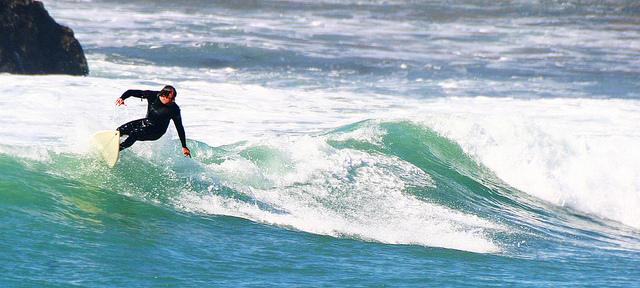Is there a wave in the picture?
Quick response, please. Yes. What is this person riding?
Be succinct. Surfboard. What color is the surfboard?
Answer briefly. White. 